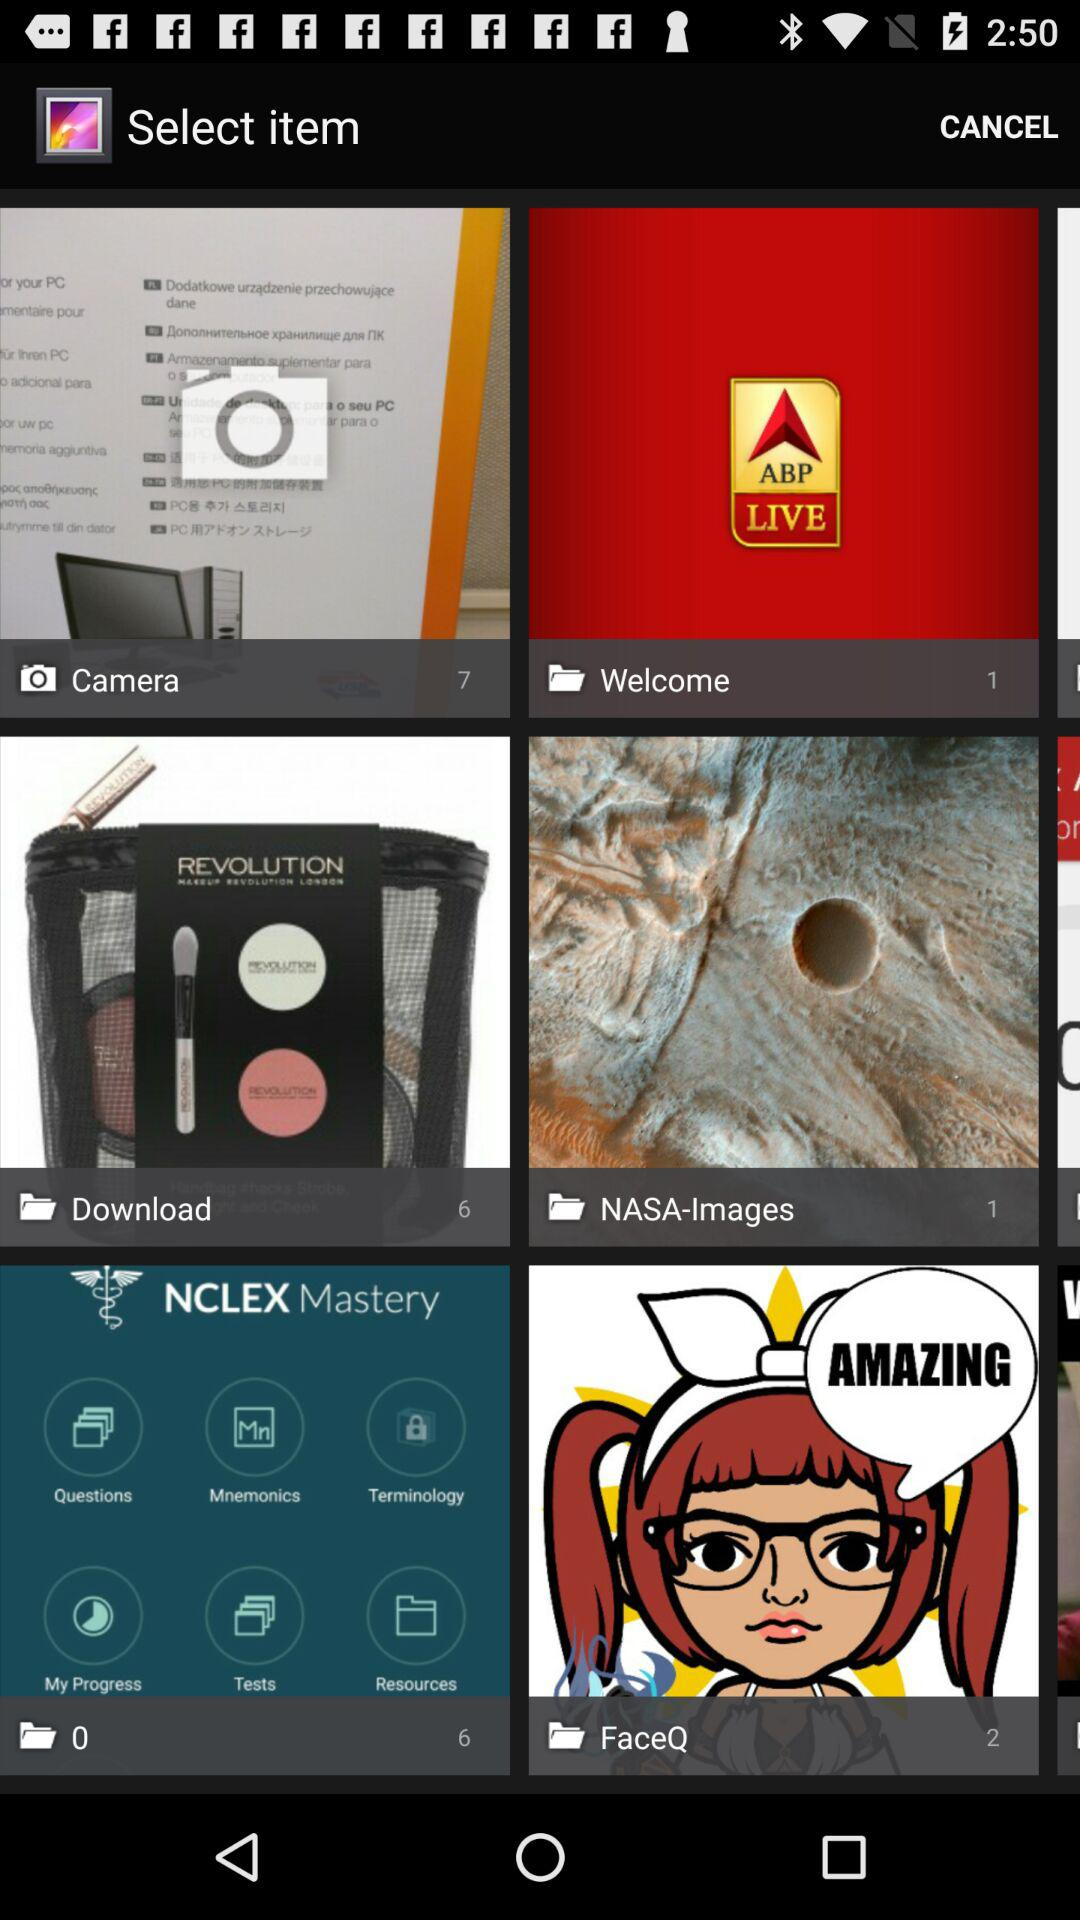What is the total number of things in "Welcome"? The total number of things in "Welcome" is 1. 